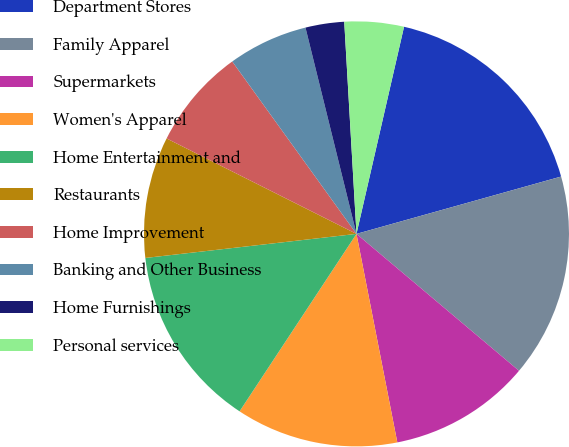<chart> <loc_0><loc_0><loc_500><loc_500><pie_chart><fcel>Department Stores<fcel>Family Apparel<fcel>Supermarkets<fcel>Women's Apparel<fcel>Home Entertainment and<fcel>Restaurants<fcel>Home Improvement<fcel>Banking and Other Business<fcel>Home Furnishings<fcel>Personal services<nl><fcel>17.06%<fcel>15.49%<fcel>10.78%<fcel>12.35%<fcel>13.92%<fcel>9.22%<fcel>7.65%<fcel>6.08%<fcel>2.94%<fcel>4.51%<nl></chart> 